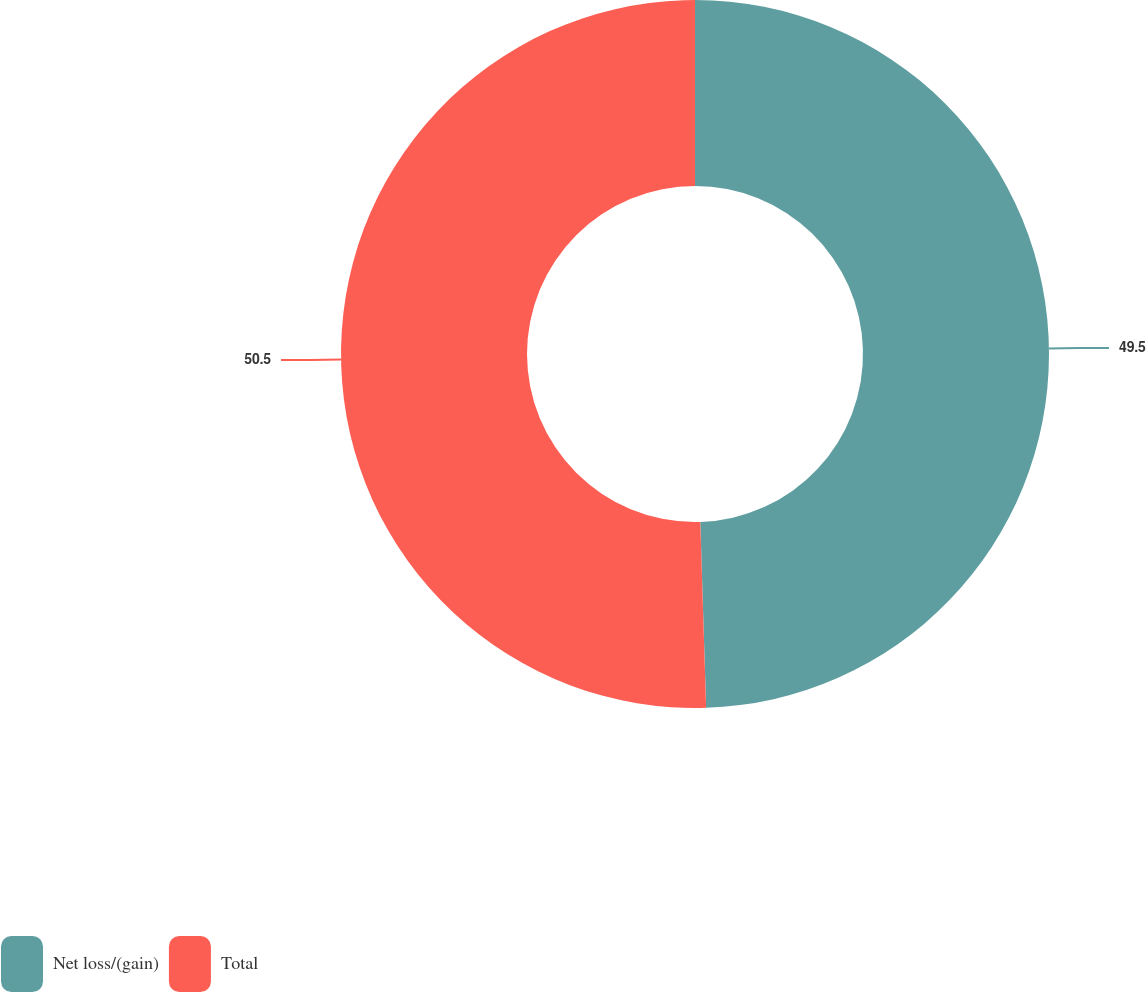Convert chart to OTSL. <chart><loc_0><loc_0><loc_500><loc_500><pie_chart><fcel>Net loss/(gain)<fcel>Total<nl><fcel>49.5%<fcel>50.5%<nl></chart> 